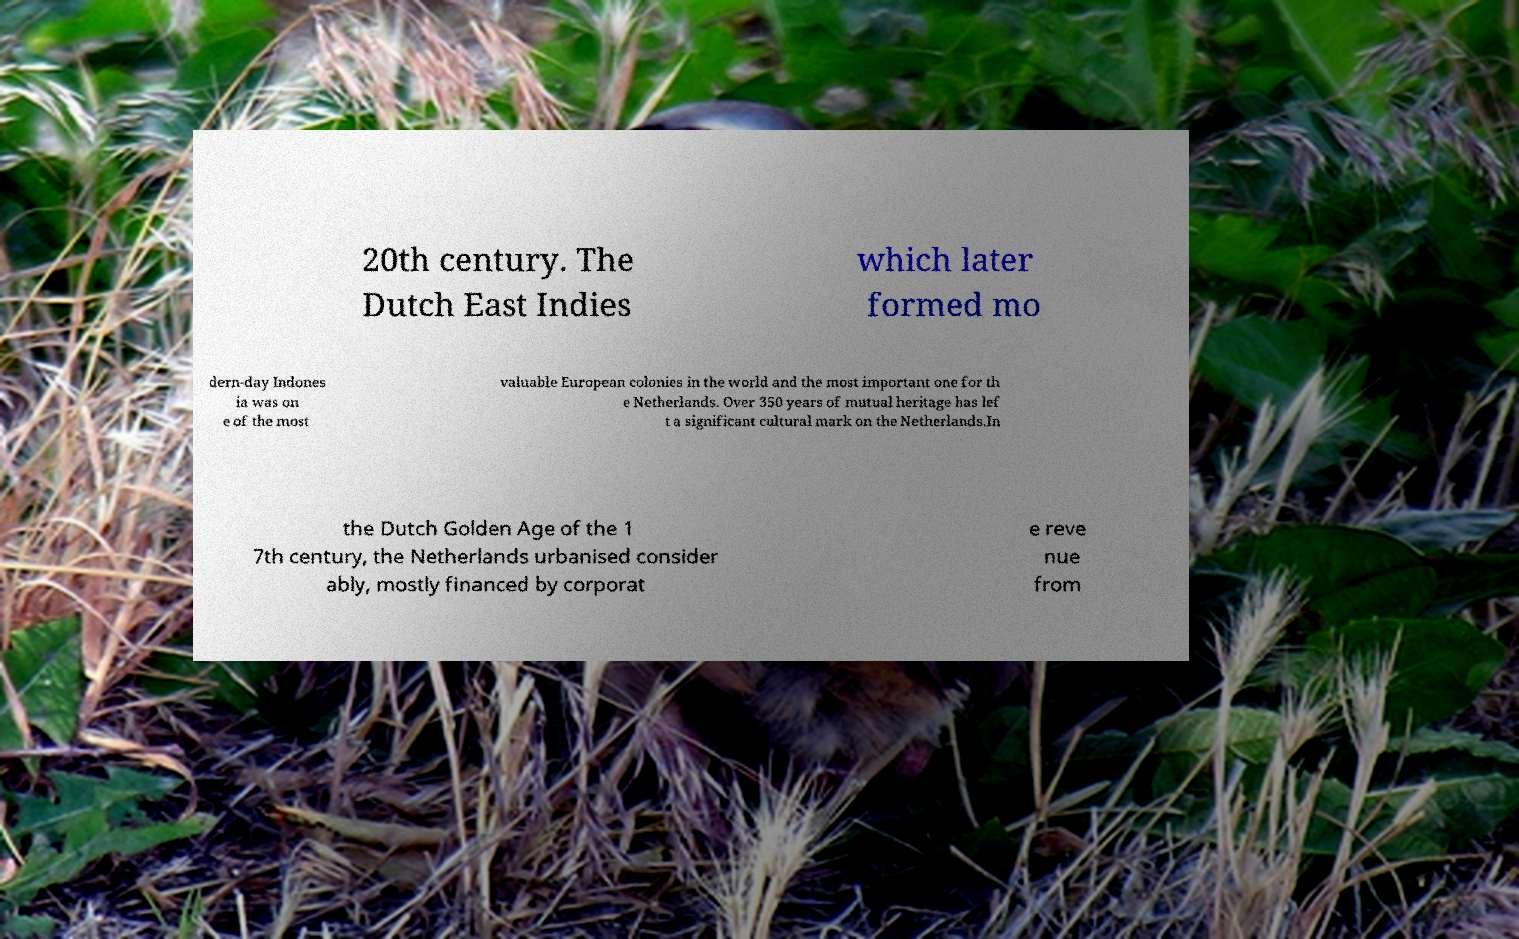Could you extract and type out the text from this image? 20th century. The Dutch East Indies which later formed mo dern-day Indones ia was on e of the most valuable European colonies in the world and the most important one for th e Netherlands. Over 350 years of mutual heritage has lef t a significant cultural mark on the Netherlands.In the Dutch Golden Age of the 1 7th century, the Netherlands urbanised consider ably, mostly financed by corporat e reve nue from 